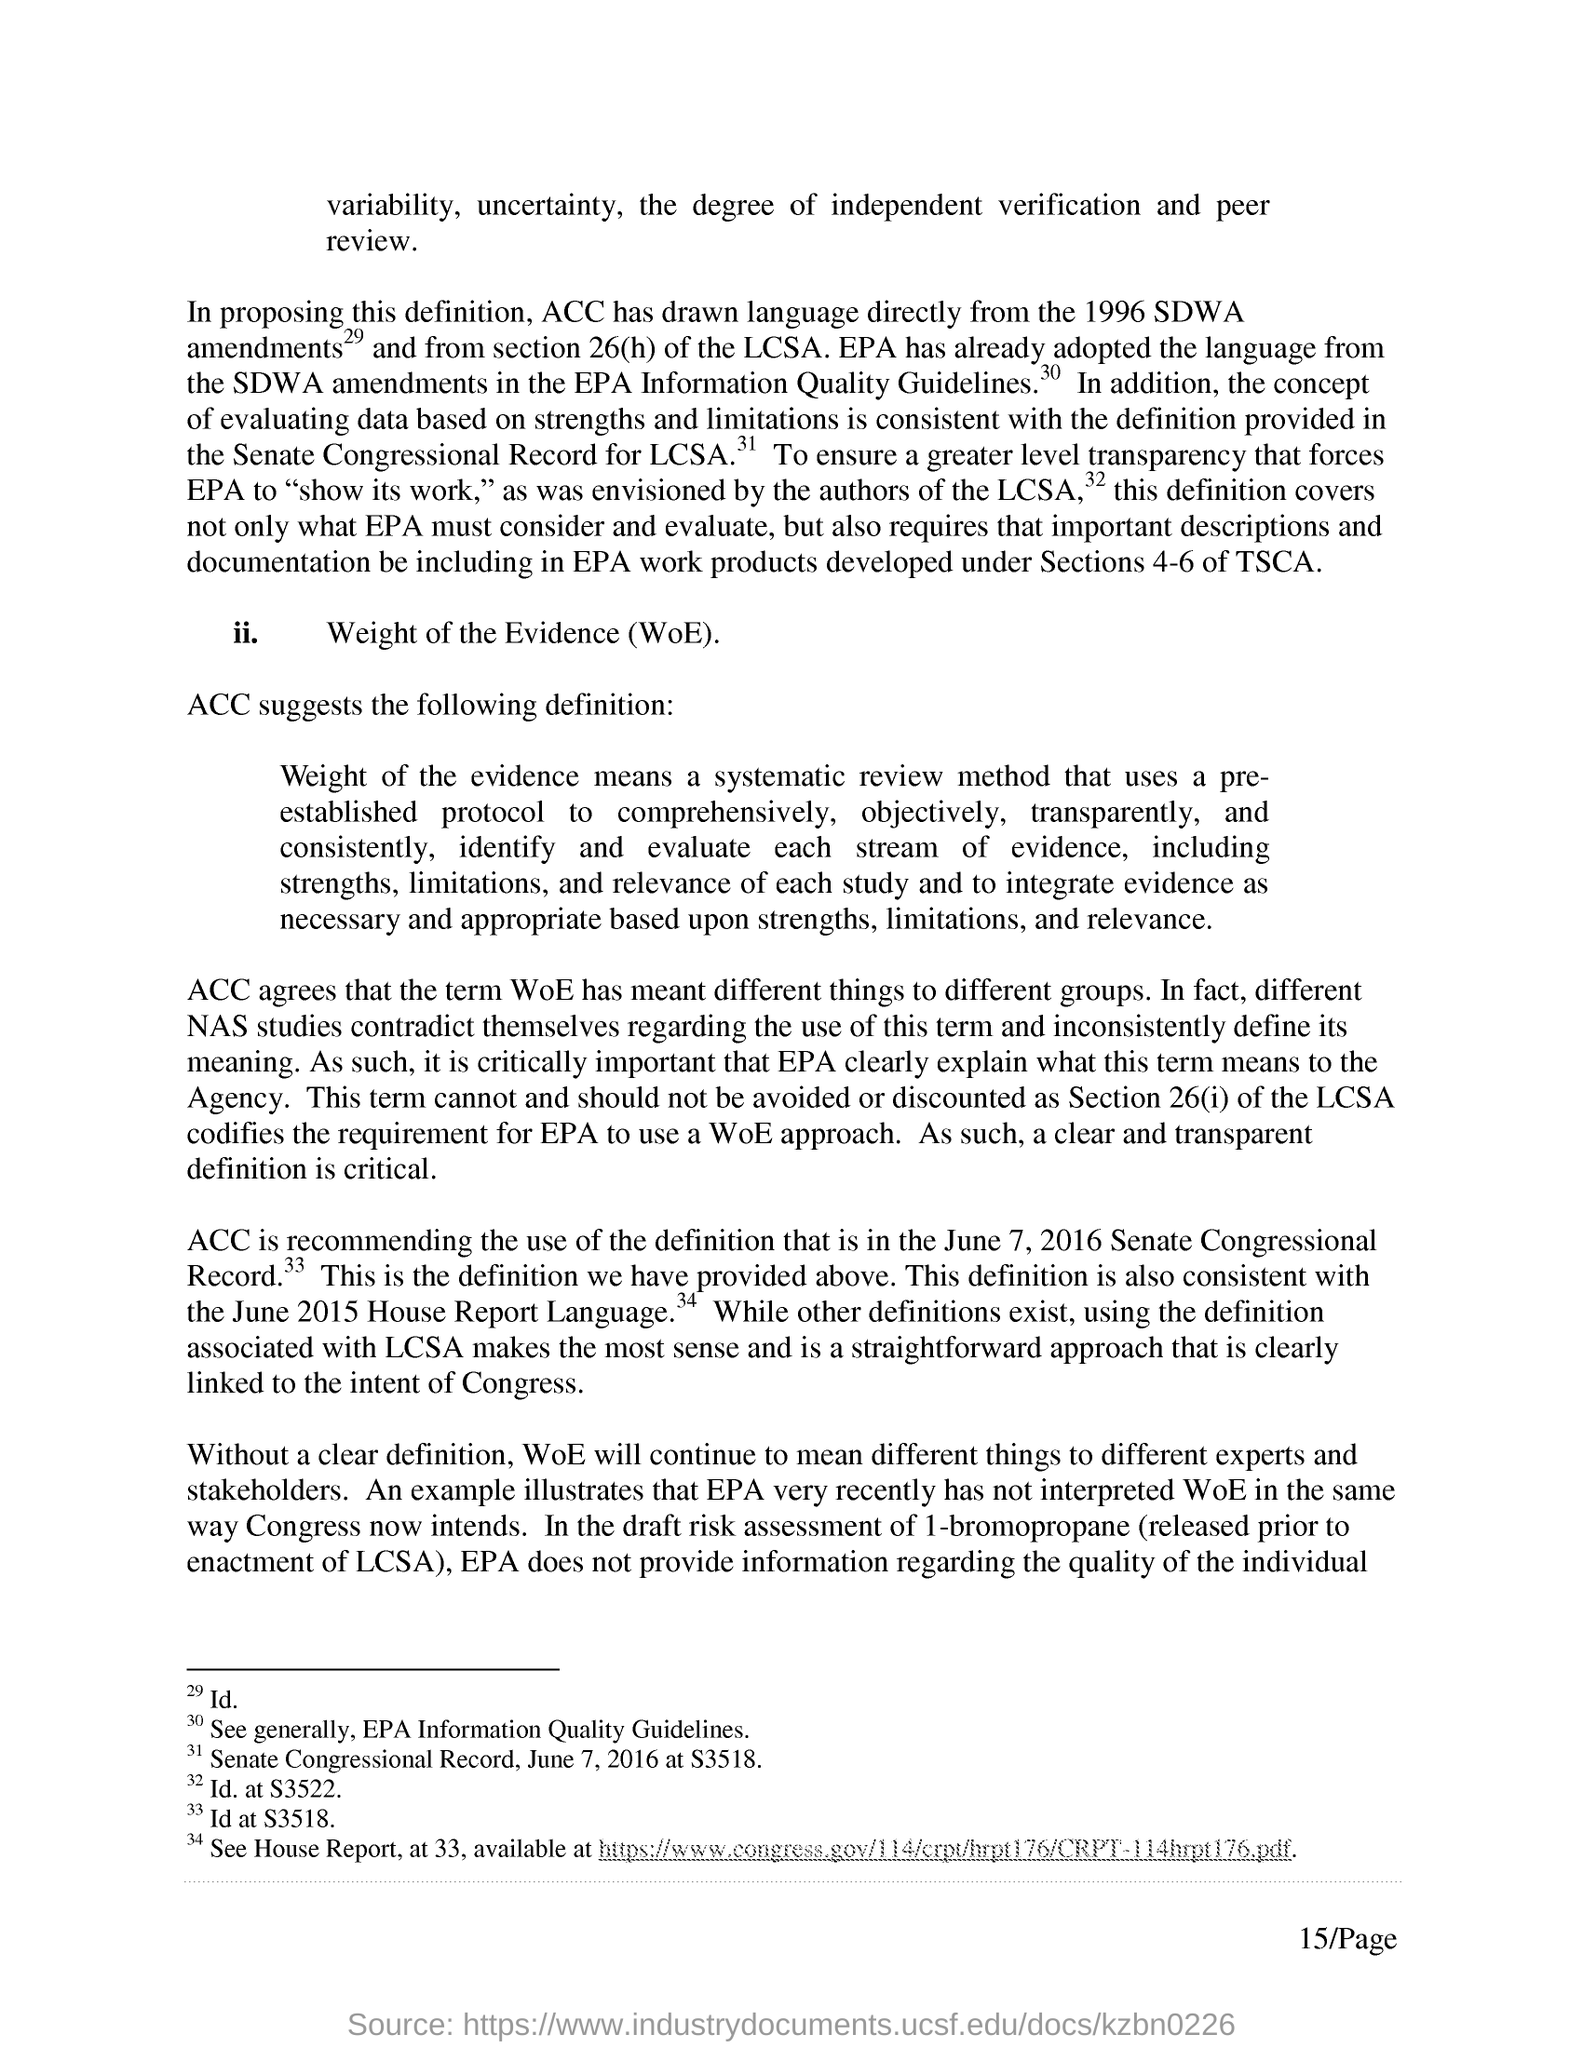Give some essential details in this illustration. The two degrees of independent verification and peer review are variability and uncertainty. The second point is named Weight of the Evidence (WoE). The term WoE has meant different things to different groups, as agreed by many. The Environmental Protection Agency (EPA) does not provide information regarding the quality of the individual. 